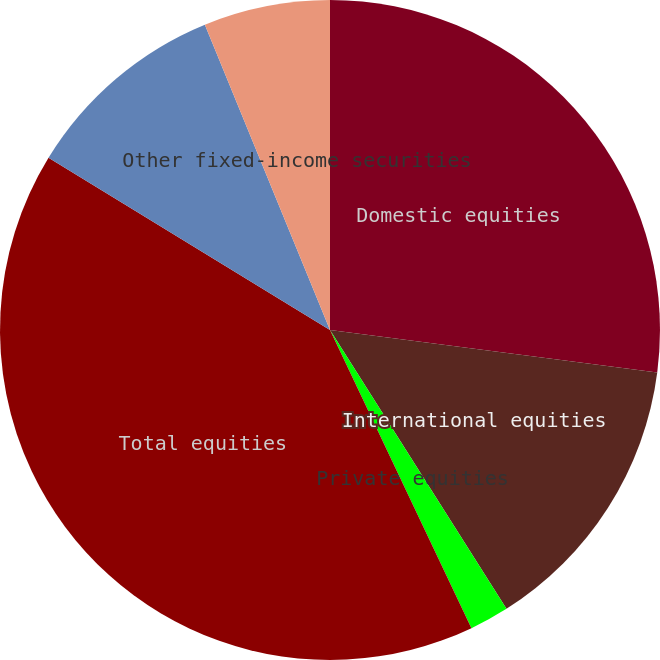Convert chart to OTSL. <chart><loc_0><loc_0><loc_500><loc_500><pie_chart><fcel>Domestic equities<fcel>International equities<fcel>Private equities<fcel>Total equities<fcel>Long-duration fixed-income<fcel>Other fixed-income securities<nl><fcel>27.06%<fcel>13.96%<fcel>1.93%<fcel>40.79%<fcel>10.07%<fcel>6.19%<nl></chart> 